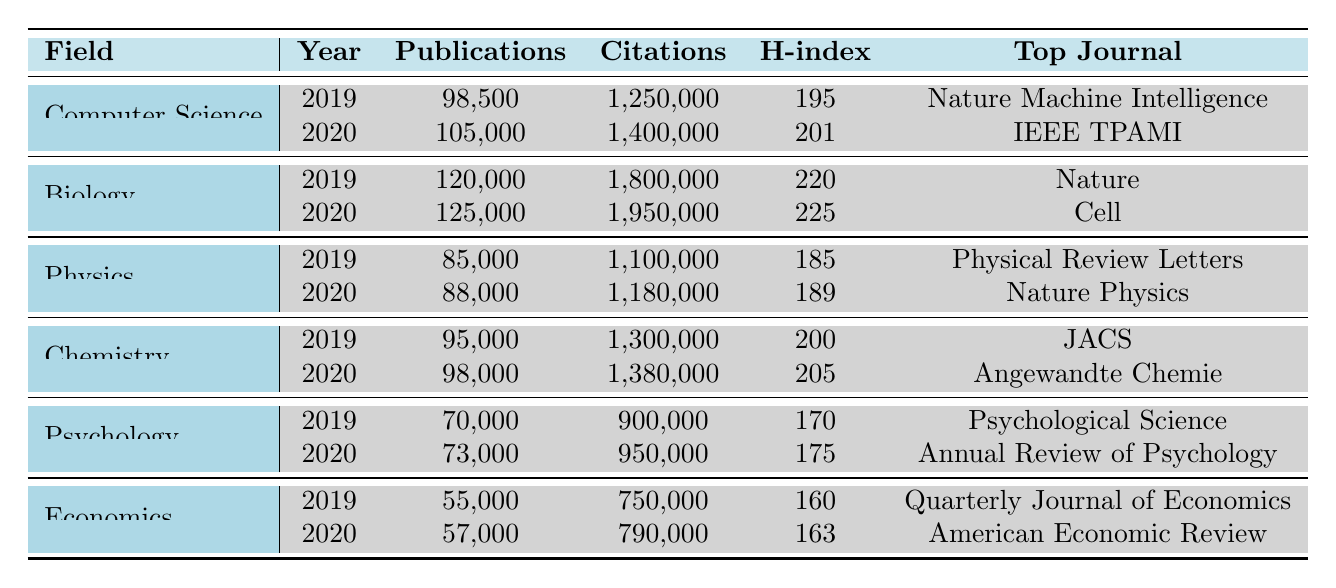What is the top journal in the field of Chemistry for the year 2020? Referring to the table, in the Chemistry section under the year 2020, the top journal listed is "Angewandte Chemie".
Answer: Angewandte Chemie How many publications were there in Biology in the year 2019? Looking at the Biology section for the year 2019, the table shows there were 120,000 publications.
Answer: 120000 Which field had the highest H-index in 2020? By examining the H-index values for each field in the year 2020, Biology has the highest H-index of 225, compared to Chemistry (205), Computer Science (201), Physics (189), Psychology (175), and Economics (163).
Answer: Biology What was the total number of citations for Economics from 2019 to 2020? The citations for Economics in 2019 is 750,000 and in 2020 is 790,000. Adding them gives us 750,000 + 790,000 = 1,540,000 total citations.
Answer: 1540000 Did the field of Psychology have more publications in 2020 than in 2019? Looking at the publications, Psychology had 70,000 publications in 2019 and 73,000 in 2020. Since 73,000 is greater than 70,000, the answer is yes.
Answer: Yes What is the difference in the number of citations between Physics and Chemistry for the year 2019? In 2019, Physics had 1,100,000 citations, and Chemistry had 1,300,000. The difference is 1,300,000 - 1,100,000 = 200,000.
Answer: 200000 How many total publications are there in the field of Computer Science over the years 2019 and 2020? For Computer Science, the number of publications in 2019 was 98,500 and in 2020 was 105,000. Therefore, the total publications are 98,500 + 105,000 = 203,500.
Answer: 203500 Which field saw a decrease in its H-index from 2019 to 2020? Comparing the H-index values, Physics decreased from 185 in 2019 to 189 in 2020, Psychology decreased from 170 in 2019 to 175 in 2020,  but no field saw a decrease as all increased.
Answer: No What was the average number of publications in the field of Economics for the years available? The number of publications in Economics for 2019 is 55,000 and for 2020 is 57,000. The average is (55,000 + 57,000) / 2 = 56,000.
Answer: 56000 